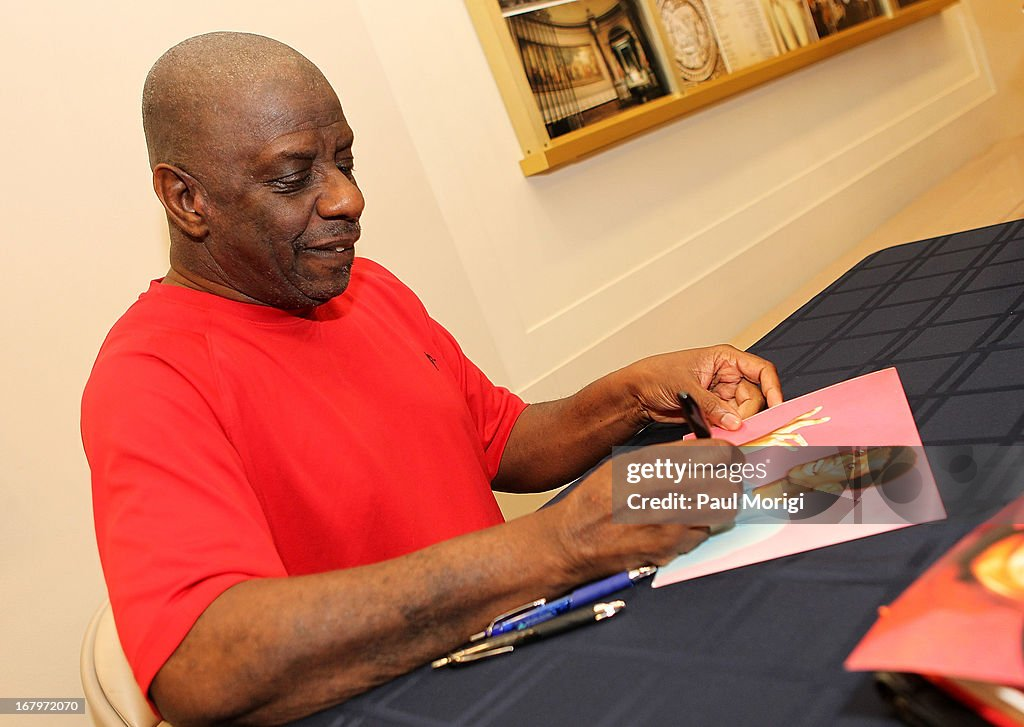Imagine the individual is signing intergalactic treaties for peace. What species might be present at this event? In an intergalactic peace treaty signing event, you might find representatives from various alien species. For example, you might see tall, blue-skinned beings from the distant planet Andromeda, reptilian diplomats from Draco Prime, and bioluminescent aquatic aliens from the oceans of Neptune. Each species might bring their unique cultural artifacts and writing instruments, contributing to a colorful and diverse atmosphere. The individual in the image could be the esteemed ambassador, facilitating peace across galaxies with each signature. 